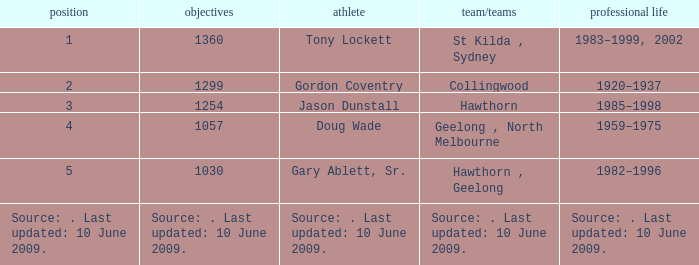In what club(s) does Tony Lockett play? St Kilda , Sydney. 